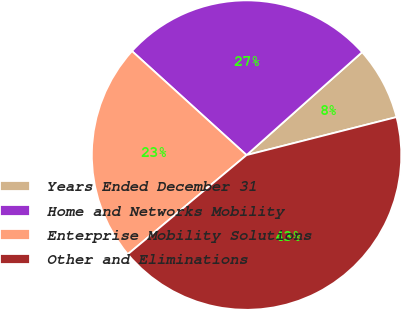Convert chart to OTSL. <chart><loc_0><loc_0><loc_500><loc_500><pie_chart><fcel>Years Ended December 31<fcel>Home and Networks Mobility<fcel>Enterprise Mobility Solutions<fcel>Other and Eliminations<nl><fcel>7.63%<fcel>26.69%<fcel>22.8%<fcel>42.88%<nl></chart> 